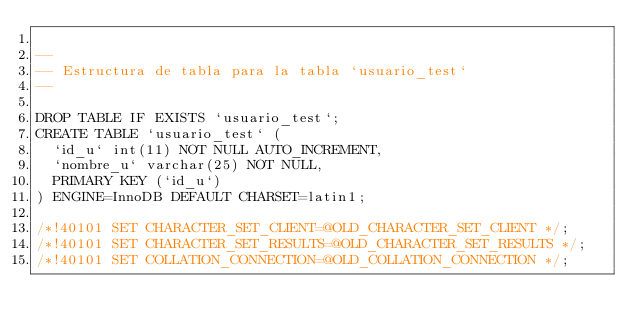Convert code to text. <code><loc_0><loc_0><loc_500><loc_500><_SQL_>
--
-- Estructura de tabla para la tabla `usuario_test`
--

DROP TABLE IF EXISTS `usuario_test`;
CREATE TABLE `usuario_test` (
  `id_u` int(11) NOT NULL AUTO_INCREMENT,
  `nombre_u` varchar(25) NOT NULL,
  PRIMARY KEY (`id_u`)
) ENGINE=InnoDB DEFAULT CHARSET=latin1;

/*!40101 SET CHARACTER_SET_CLIENT=@OLD_CHARACTER_SET_CLIENT */;
/*!40101 SET CHARACTER_SET_RESULTS=@OLD_CHARACTER_SET_RESULTS */;
/*!40101 SET COLLATION_CONNECTION=@OLD_COLLATION_CONNECTION */;
</code> 